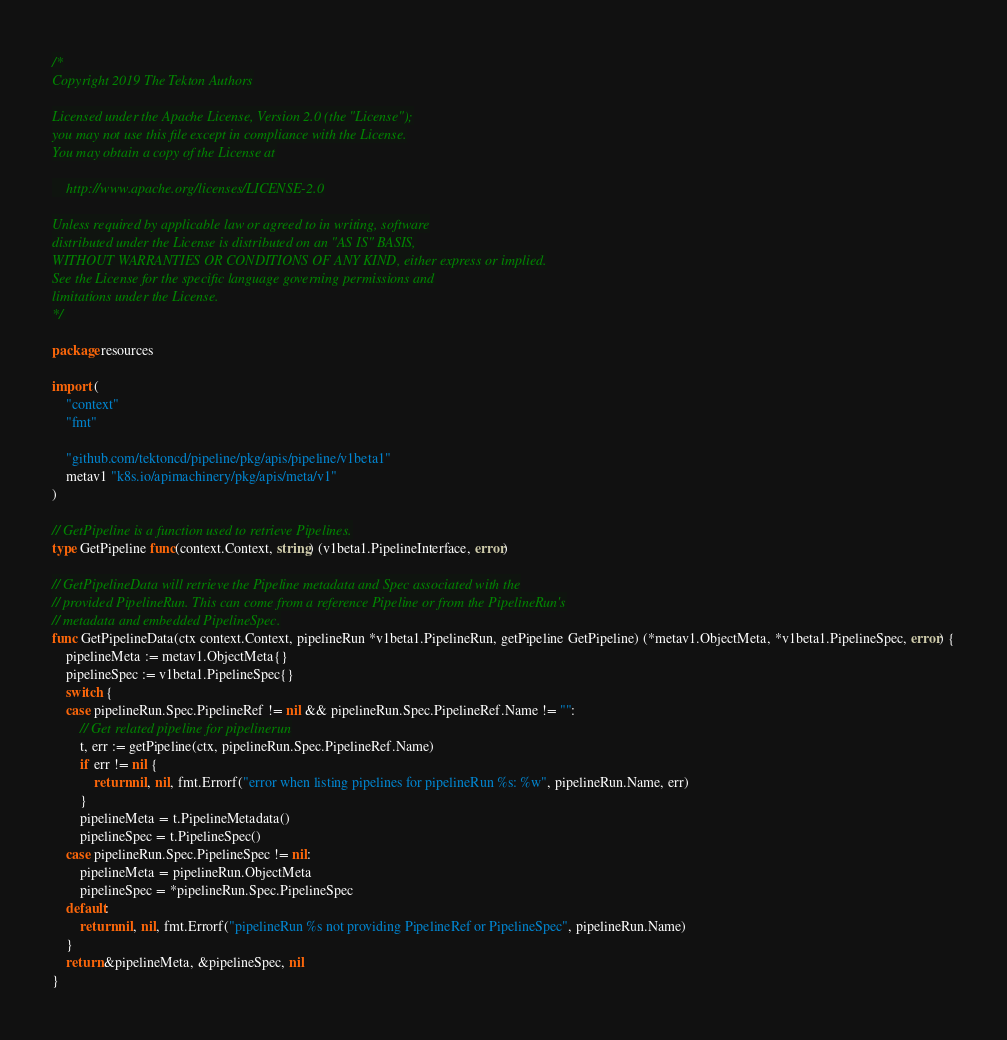Convert code to text. <code><loc_0><loc_0><loc_500><loc_500><_Go_>/*
Copyright 2019 The Tekton Authors

Licensed under the Apache License, Version 2.0 (the "License");
you may not use this file except in compliance with the License.
You may obtain a copy of the License at

    http://www.apache.org/licenses/LICENSE-2.0

Unless required by applicable law or agreed to in writing, software
distributed under the License is distributed on an "AS IS" BASIS,
WITHOUT WARRANTIES OR CONDITIONS OF ANY KIND, either express or implied.
See the License for the specific language governing permissions and
limitations under the License.
*/

package resources

import (
	"context"
	"fmt"

	"github.com/tektoncd/pipeline/pkg/apis/pipeline/v1beta1"
	metav1 "k8s.io/apimachinery/pkg/apis/meta/v1"
)

// GetPipeline is a function used to retrieve Pipelines.
type GetPipeline func(context.Context, string) (v1beta1.PipelineInterface, error)

// GetPipelineData will retrieve the Pipeline metadata and Spec associated with the
// provided PipelineRun. This can come from a reference Pipeline or from the PipelineRun's
// metadata and embedded PipelineSpec.
func GetPipelineData(ctx context.Context, pipelineRun *v1beta1.PipelineRun, getPipeline GetPipeline) (*metav1.ObjectMeta, *v1beta1.PipelineSpec, error) {
	pipelineMeta := metav1.ObjectMeta{}
	pipelineSpec := v1beta1.PipelineSpec{}
	switch {
	case pipelineRun.Spec.PipelineRef != nil && pipelineRun.Spec.PipelineRef.Name != "":
		// Get related pipeline for pipelinerun
		t, err := getPipeline(ctx, pipelineRun.Spec.PipelineRef.Name)
		if err != nil {
			return nil, nil, fmt.Errorf("error when listing pipelines for pipelineRun %s: %w", pipelineRun.Name, err)
		}
		pipelineMeta = t.PipelineMetadata()
		pipelineSpec = t.PipelineSpec()
	case pipelineRun.Spec.PipelineSpec != nil:
		pipelineMeta = pipelineRun.ObjectMeta
		pipelineSpec = *pipelineRun.Spec.PipelineSpec
	default:
		return nil, nil, fmt.Errorf("pipelineRun %s not providing PipelineRef or PipelineSpec", pipelineRun.Name)
	}
	return &pipelineMeta, &pipelineSpec, nil
}
</code> 